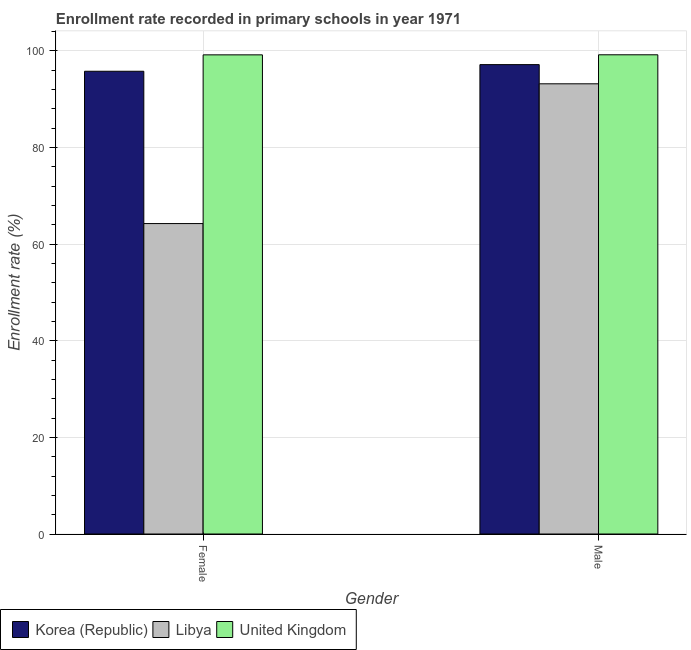How many different coloured bars are there?
Make the answer very short. 3. How many groups of bars are there?
Your answer should be compact. 2. Are the number of bars on each tick of the X-axis equal?
Ensure brevity in your answer.  Yes. How many bars are there on the 2nd tick from the left?
Offer a terse response. 3. How many bars are there on the 1st tick from the right?
Your answer should be compact. 3. What is the enrollment rate of female students in United Kingdom?
Keep it short and to the point. 99.2. Across all countries, what is the maximum enrollment rate of male students?
Keep it short and to the point. 99.21. Across all countries, what is the minimum enrollment rate of female students?
Ensure brevity in your answer.  64.27. In which country was the enrollment rate of male students minimum?
Keep it short and to the point. Libya. What is the total enrollment rate of male students in the graph?
Provide a short and direct response. 289.59. What is the difference between the enrollment rate of female students in Korea (Republic) and that in Libya?
Keep it short and to the point. 31.53. What is the difference between the enrollment rate of female students in Korea (Republic) and the enrollment rate of male students in United Kingdom?
Offer a very short reply. -3.41. What is the average enrollment rate of male students per country?
Your response must be concise. 96.53. What is the difference between the enrollment rate of female students and enrollment rate of male students in United Kingdom?
Give a very brief answer. -0.01. What is the ratio of the enrollment rate of female students in Libya to that in United Kingdom?
Give a very brief answer. 0.65. In how many countries, is the enrollment rate of female students greater than the average enrollment rate of female students taken over all countries?
Offer a terse response. 2. What does the 2nd bar from the left in Male represents?
Your answer should be compact. Libya. What does the 2nd bar from the right in Female represents?
Keep it short and to the point. Libya. How many bars are there?
Keep it short and to the point. 6. Are all the bars in the graph horizontal?
Keep it short and to the point. No. How many countries are there in the graph?
Your answer should be very brief. 3. What is the difference between two consecutive major ticks on the Y-axis?
Provide a succinct answer. 20. Does the graph contain any zero values?
Give a very brief answer. No. Does the graph contain grids?
Provide a short and direct response. Yes. How are the legend labels stacked?
Offer a terse response. Horizontal. What is the title of the graph?
Offer a terse response. Enrollment rate recorded in primary schools in year 1971. What is the label or title of the Y-axis?
Offer a very short reply. Enrollment rate (%). What is the Enrollment rate (%) in Korea (Republic) in Female?
Ensure brevity in your answer.  95.8. What is the Enrollment rate (%) of Libya in Female?
Make the answer very short. 64.27. What is the Enrollment rate (%) in United Kingdom in Female?
Give a very brief answer. 99.2. What is the Enrollment rate (%) of Korea (Republic) in Male?
Your answer should be very brief. 97.18. What is the Enrollment rate (%) of Libya in Male?
Provide a short and direct response. 93.2. What is the Enrollment rate (%) in United Kingdom in Male?
Make the answer very short. 99.21. Across all Gender, what is the maximum Enrollment rate (%) in Korea (Republic)?
Ensure brevity in your answer.  97.18. Across all Gender, what is the maximum Enrollment rate (%) of Libya?
Provide a succinct answer. 93.2. Across all Gender, what is the maximum Enrollment rate (%) of United Kingdom?
Your response must be concise. 99.21. Across all Gender, what is the minimum Enrollment rate (%) of Korea (Republic)?
Offer a terse response. 95.8. Across all Gender, what is the minimum Enrollment rate (%) in Libya?
Your answer should be very brief. 64.27. Across all Gender, what is the minimum Enrollment rate (%) of United Kingdom?
Offer a very short reply. 99.2. What is the total Enrollment rate (%) in Korea (Republic) in the graph?
Offer a very short reply. 192.98. What is the total Enrollment rate (%) in Libya in the graph?
Keep it short and to the point. 157.47. What is the total Enrollment rate (%) in United Kingdom in the graph?
Offer a terse response. 198.41. What is the difference between the Enrollment rate (%) of Korea (Republic) in Female and that in Male?
Your answer should be compact. -1.37. What is the difference between the Enrollment rate (%) in Libya in Female and that in Male?
Your answer should be very brief. -28.93. What is the difference between the Enrollment rate (%) in United Kingdom in Female and that in Male?
Make the answer very short. -0.01. What is the difference between the Enrollment rate (%) in Korea (Republic) in Female and the Enrollment rate (%) in Libya in Male?
Provide a short and direct response. 2.6. What is the difference between the Enrollment rate (%) of Korea (Republic) in Female and the Enrollment rate (%) of United Kingdom in Male?
Your answer should be compact. -3.41. What is the difference between the Enrollment rate (%) of Libya in Female and the Enrollment rate (%) of United Kingdom in Male?
Offer a terse response. -34.94. What is the average Enrollment rate (%) of Korea (Republic) per Gender?
Offer a very short reply. 96.49. What is the average Enrollment rate (%) of Libya per Gender?
Ensure brevity in your answer.  78.74. What is the average Enrollment rate (%) in United Kingdom per Gender?
Make the answer very short. 99.21. What is the difference between the Enrollment rate (%) of Korea (Republic) and Enrollment rate (%) of Libya in Female?
Keep it short and to the point. 31.53. What is the difference between the Enrollment rate (%) in Korea (Republic) and Enrollment rate (%) in United Kingdom in Female?
Provide a short and direct response. -3.4. What is the difference between the Enrollment rate (%) of Libya and Enrollment rate (%) of United Kingdom in Female?
Offer a terse response. -34.93. What is the difference between the Enrollment rate (%) of Korea (Republic) and Enrollment rate (%) of Libya in Male?
Your answer should be compact. 3.97. What is the difference between the Enrollment rate (%) in Korea (Republic) and Enrollment rate (%) in United Kingdom in Male?
Give a very brief answer. -2.04. What is the difference between the Enrollment rate (%) in Libya and Enrollment rate (%) in United Kingdom in Male?
Offer a very short reply. -6.01. What is the ratio of the Enrollment rate (%) of Korea (Republic) in Female to that in Male?
Your answer should be compact. 0.99. What is the ratio of the Enrollment rate (%) in Libya in Female to that in Male?
Make the answer very short. 0.69. What is the difference between the highest and the second highest Enrollment rate (%) in Korea (Republic)?
Make the answer very short. 1.37. What is the difference between the highest and the second highest Enrollment rate (%) in Libya?
Keep it short and to the point. 28.93. What is the difference between the highest and the second highest Enrollment rate (%) in United Kingdom?
Ensure brevity in your answer.  0.01. What is the difference between the highest and the lowest Enrollment rate (%) in Korea (Republic)?
Give a very brief answer. 1.37. What is the difference between the highest and the lowest Enrollment rate (%) of Libya?
Give a very brief answer. 28.93. What is the difference between the highest and the lowest Enrollment rate (%) of United Kingdom?
Make the answer very short. 0.01. 